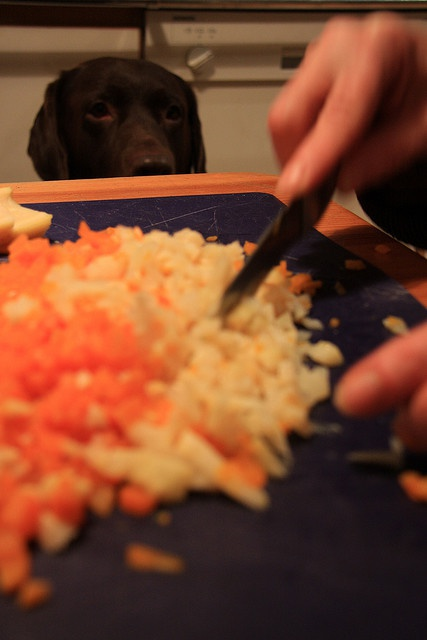Describe the objects in this image and their specific colors. I can see people in black, maroon, salmon, and brown tones, dog in black, maroon, and gray tones, carrot in black, red, orange, and salmon tones, carrot in black, red, and brown tones, and knife in black, maroon, and brown tones in this image. 